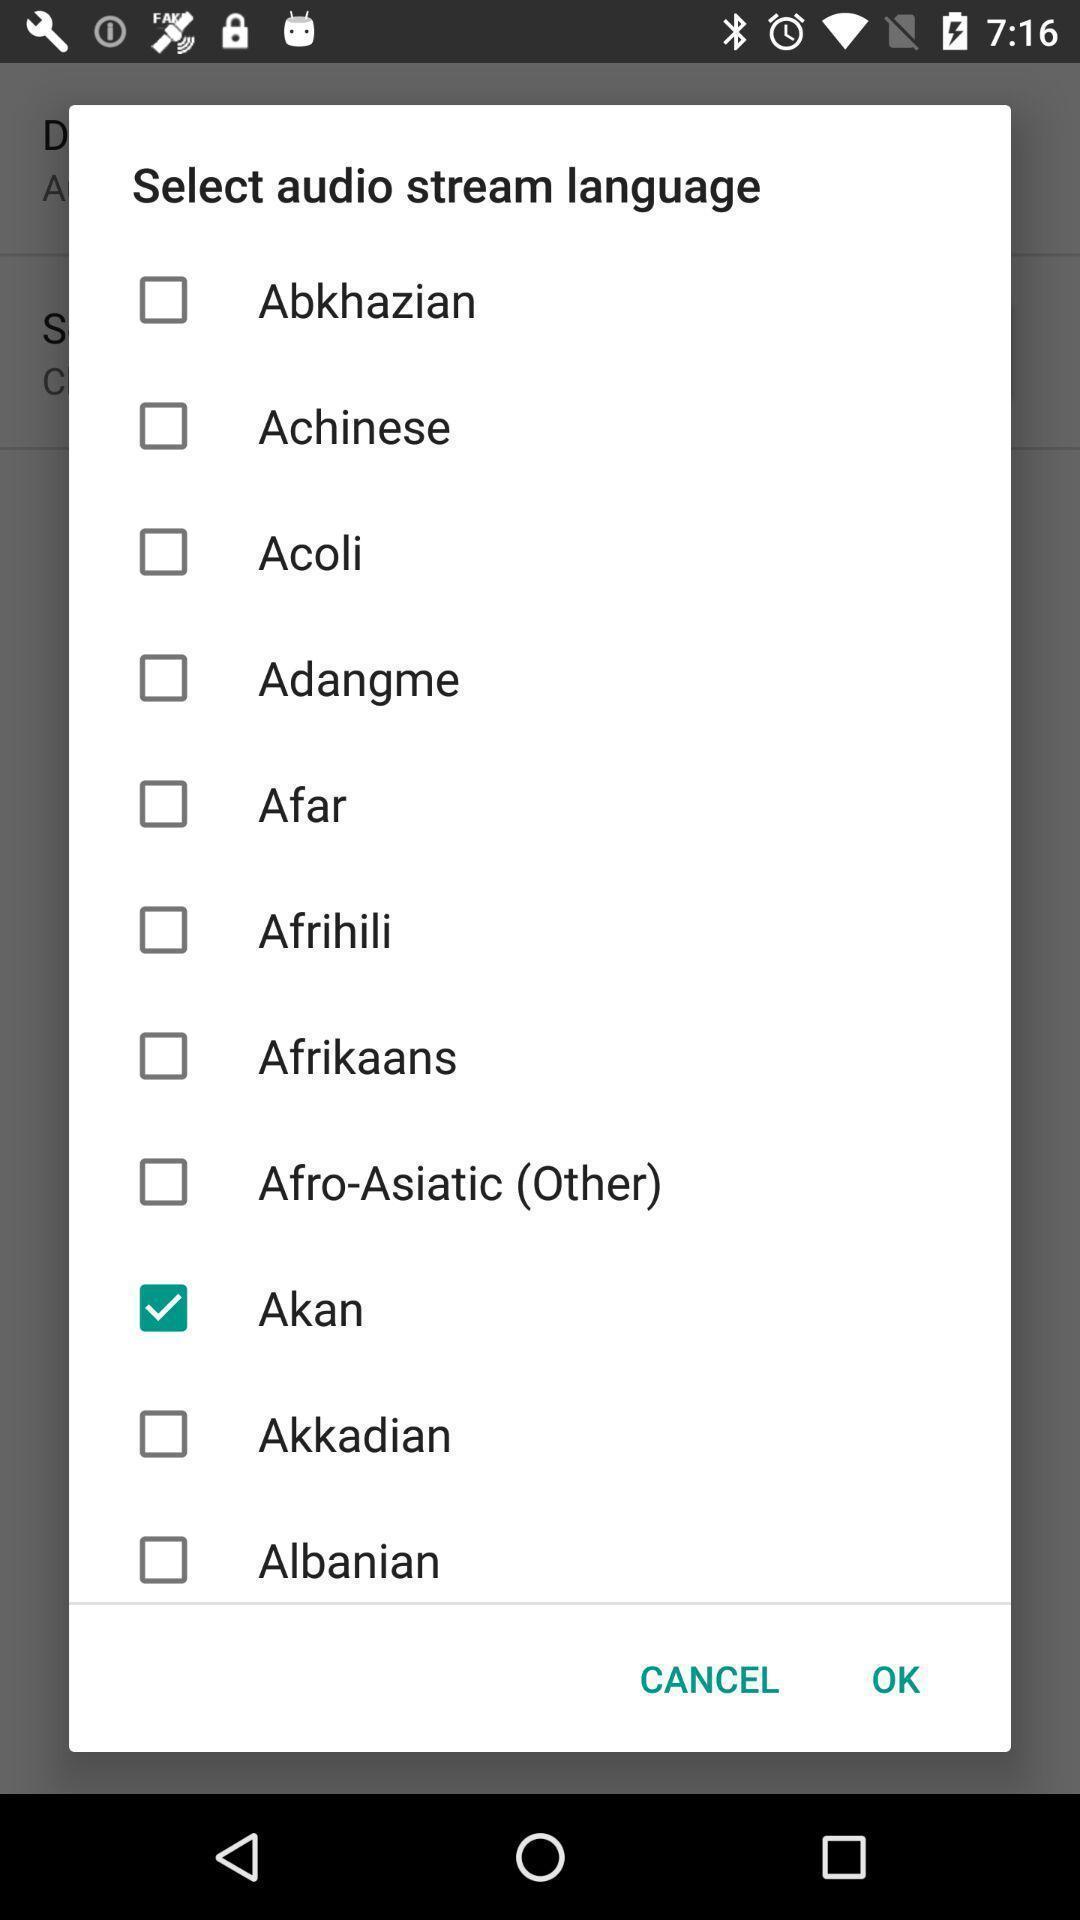Tell me about the visual elements in this screen capture. Pop-up showing multiple languages to select. 